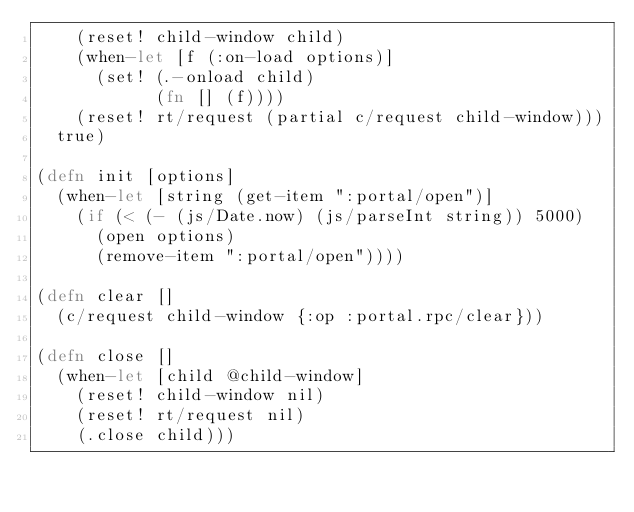<code> <loc_0><loc_0><loc_500><loc_500><_Clojure_>    (reset! child-window child)
    (when-let [f (:on-load options)]
      (set! (.-onload child)
            (fn [] (f))))
    (reset! rt/request (partial c/request child-window)))
  true)

(defn init [options]
  (when-let [string (get-item ":portal/open")]
    (if (< (- (js/Date.now) (js/parseInt string)) 5000)
      (open options)
      (remove-item ":portal/open"))))

(defn clear []
  (c/request child-window {:op :portal.rpc/clear}))

(defn close []
  (when-let [child @child-window]
    (reset! child-window nil)
    (reset! rt/request nil)
    (.close child)))
</code> 